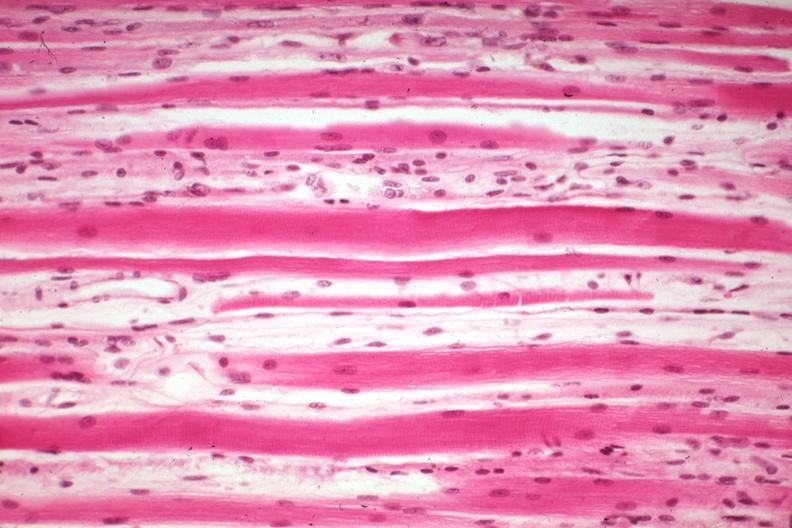does this image show high excellent steroid induced atrophy?
Answer the question using a single word or phrase. Yes 